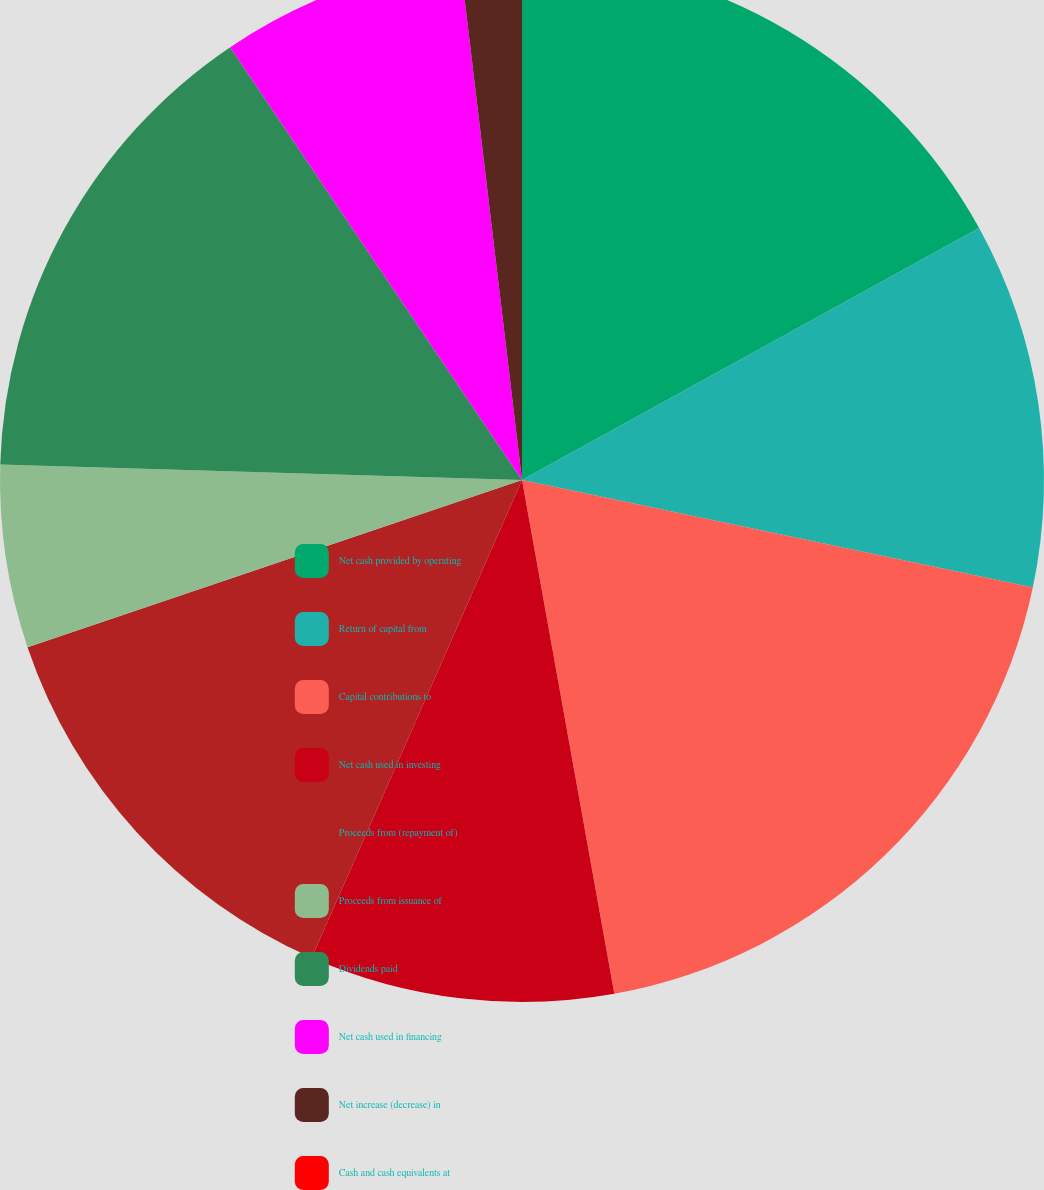Convert chart to OTSL. <chart><loc_0><loc_0><loc_500><loc_500><pie_chart><fcel>Net cash provided by operating<fcel>Return of capital from<fcel>Capital contributions to<fcel>Net cash used in investing<fcel>Proceeds from (repayment of)<fcel>Proceeds from issuance of<fcel>Dividends paid<fcel>Net cash used in financing<fcel>Net increase (decrease) in<fcel>Cash and cash equivalents at<nl><fcel>16.98%<fcel>11.32%<fcel>18.87%<fcel>9.43%<fcel>13.21%<fcel>5.66%<fcel>15.09%<fcel>7.55%<fcel>1.89%<fcel>0.0%<nl></chart> 